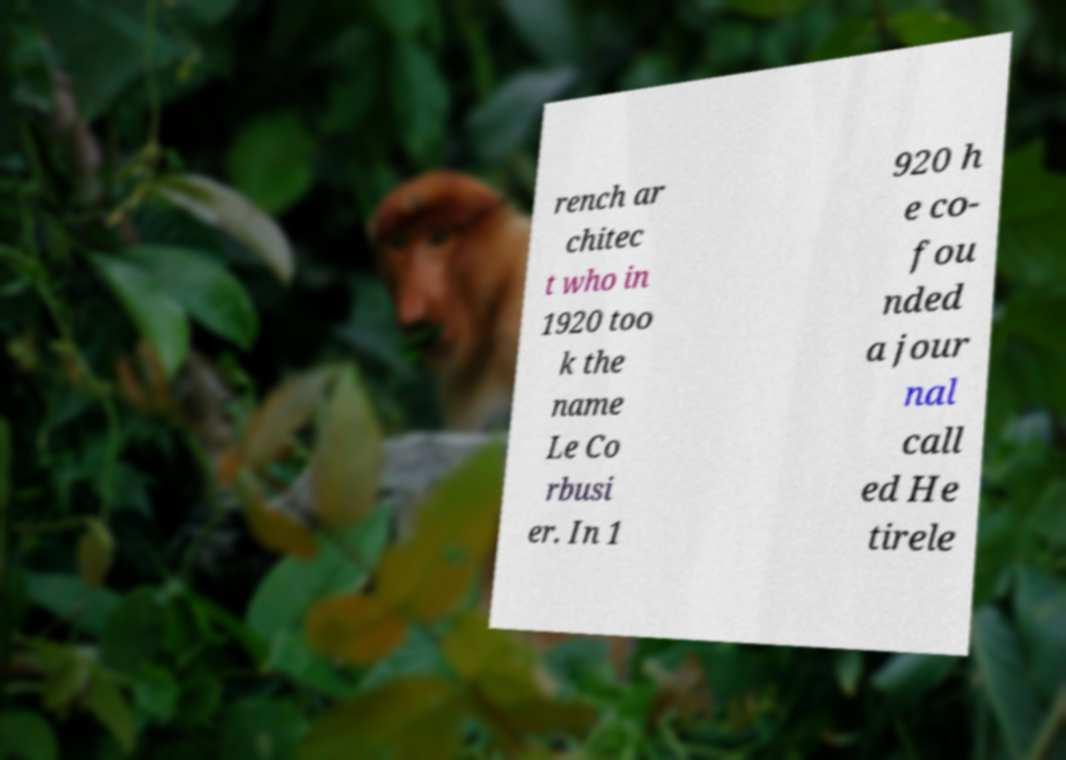Please read and relay the text visible in this image. What does it say? rench ar chitec t who in 1920 too k the name Le Co rbusi er. In 1 920 h e co- fou nded a jour nal call ed He tirele 